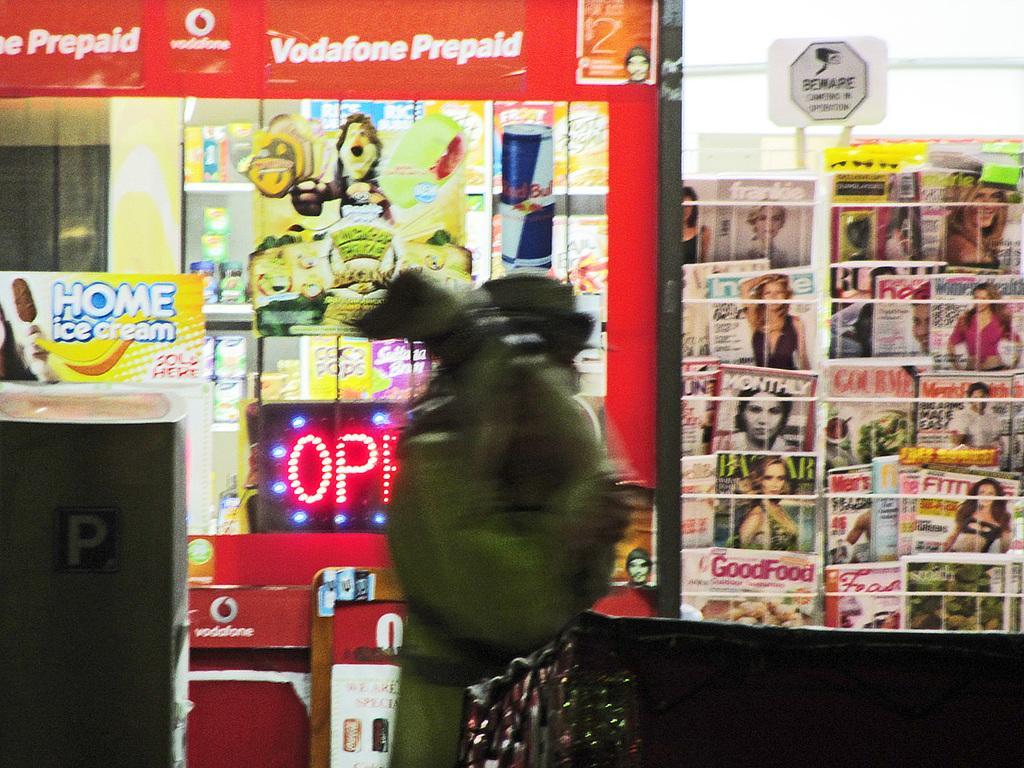Please provide a concise description of this image. In this image there is a store. On the right we can see books placed in the stand. In the center there is an object and we can see posters pasted on the glass. There is a board and we can see an object. 